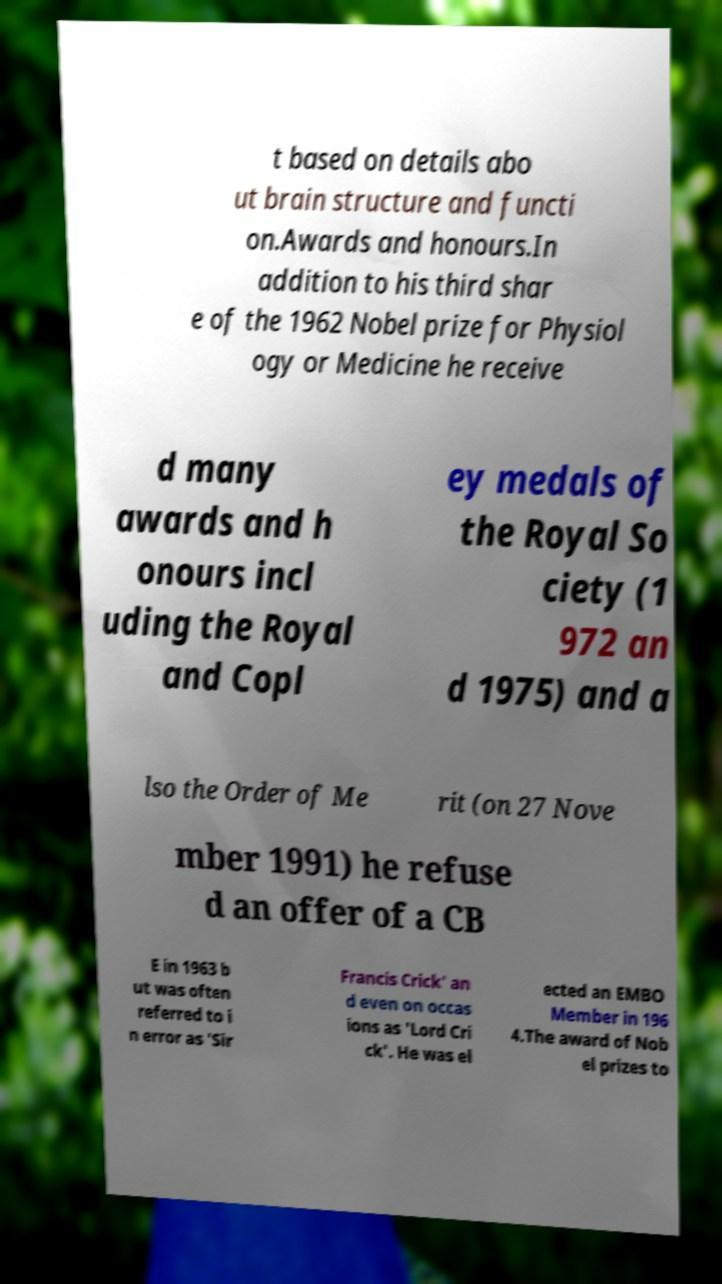For documentation purposes, I need the text within this image transcribed. Could you provide that? t based on details abo ut brain structure and functi on.Awards and honours.In addition to his third shar e of the 1962 Nobel prize for Physiol ogy or Medicine he receive d many awards and h onours incl uding the Royal and Copl ey medals of the Royal So ciety (1 972 an d 1975) and a lso the Order of Me rit (on 27 Nove mber 1991) he refuse d an offer of a CB E in 1963 b ut was often referred to i n error as 'Sir Francis Crick' an d even on occas ions as 'Lord Cri ck'. He was el ected an EMBO Member in 196 4.The award of Nob el prizes to 